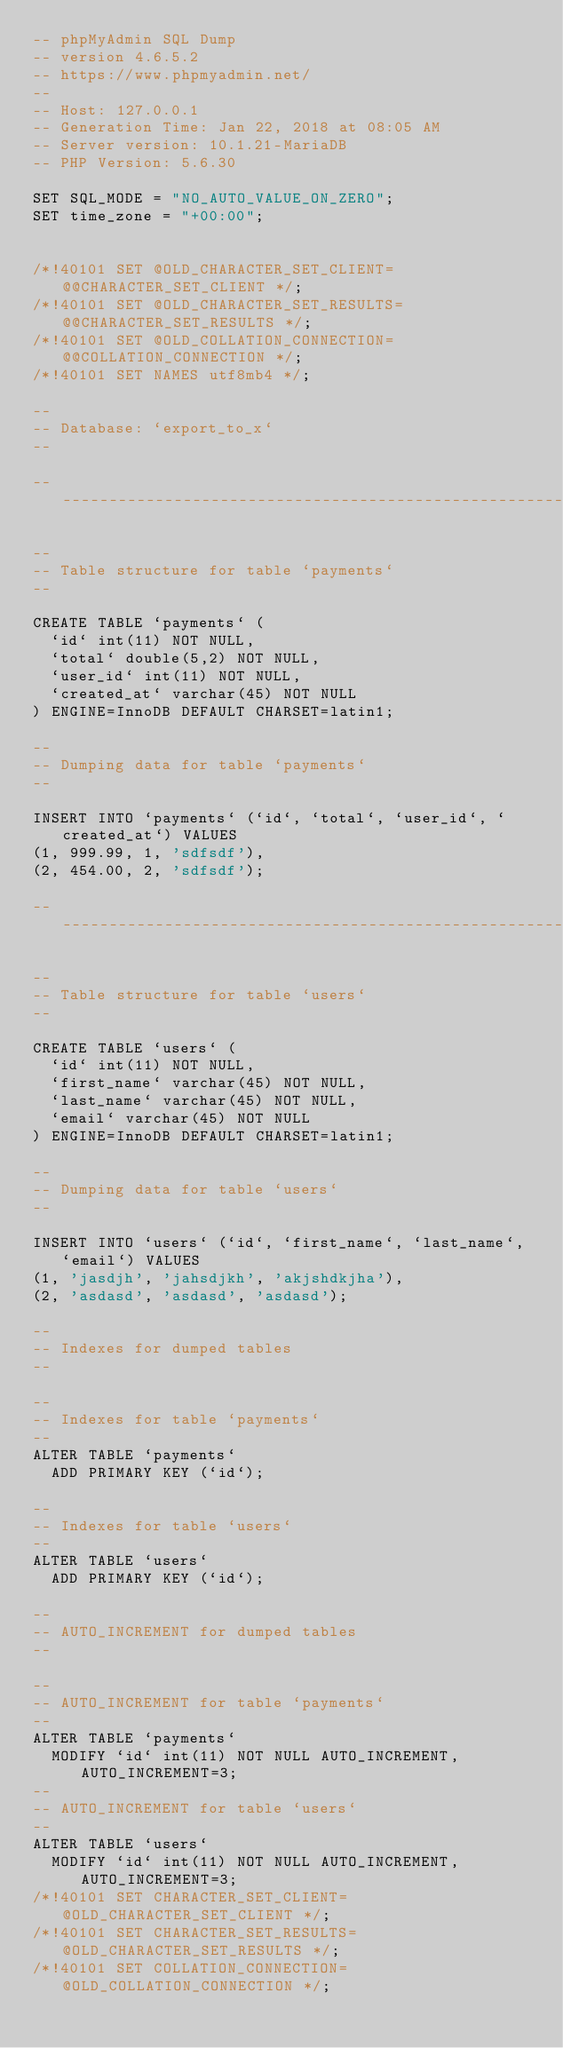<code> <loc_0><loc_0><loc_500><loc_500><_SQL_>-- phpMyAdmin SQL Dump
-- version 4.6.5.2
-- https://www.phpmyadmin.net/
--
-- Host: 127.0.0.1
-- Generation Time: Jan 22, 2018 at 08:05 AM
-- Server version: 10.1.21-MariaDB
-- PHP Version: 5.6.30

SET SQL_MODE = "NO_AUTO_VALUE_ON_ZERO";
SET time_zone = "+00:00";


/*!40101 SET @OLD_CHARACTER_SET_CLIENT=@@CHARACTER_SET_CLIENT */;
/*!40101 SET @OLD_CHARACTER_SET_RESULTS=@@CHARACTER_SET_RESULTS */;
/*!40101 SET @OLD_COLLATION_CONNECTION=@@COLLATION_CONNECTION */;
/*!40101 SET NAMES utf8mb4 */;

--
-- Database: `export_to_x`
--

-- --------------------------------------------------------

--
-- Table structure for table `payments`
--

CREATE TABLE `payments` (
  `id` int(11) NOT NULL,
  `total` double(5,2) NOT NULL,
  `user_id` int(11) NOT NULL,
  `created_at` varchar(45) NOT NULL
) ENGINE=InnoDB DEFAULT CHARSET=latin1;

--
-- Dumping data for table `payments`
--

INSERT INTO `payments` (`id`, `total`, `user_id`, `created_at`) VALUES
(1, 999.99, 1, 'sdfsdf'),
(2, 454.00, 2, 'sdfsdf');

-- --------------------------------------------------------

--
-- Table structure for table `users`
--

CREATE TABLE `users` (
  `id` int(11) NOT NULL,
  `first_name` varchar(45) NOT NULL,
  `last_name` varchar(45) NOT NULL,
  `email` varchar(45) NOT NULL
) ENGINE=InnoDB DEFAULT CHARSET=latin1;

--
-- Dumping data for table `users`
--

INSERT INTO `users` (`id`, `first_name`, `last_name`, `email`) VALUES
(1, 'jasdjh', 'jahsdjkh', 'akjshdkjha'),
(2, 'asdasd', 'asdasd', 'asdasd');

--
-- Indexes for dumped tables
--

--
-- Indexes for table `payments`
--
ALTER TABLE `payments`
  ADD PRIMARY KEY (`id`);

--
-- Indexes for table `users`
--
ALTER TABLE `users`
  ADD PRIMARY KEY (`id`);

--
-- AUTO_INCREMENT for dumped tables
--

--
-- AUTO_INCREMENT for table `payments`
--
ALTER TABLE `payments`
  MODIFY `id` int(11) NOT NULL AUTO_INCREMENT, AUTO_INCREMENT=3;
--
-- AUTO_INCREMENT for table `users`
--
ALTER TABLE `users`
  MODIFY `id` int(11) NOT NULL AUTO_INCREMENT, AUTO_INCREMENT=3;
/*!40101 SET CHARACTER_SET_CLIENT=@OLD_CHARACTER_SET_CLIENT */;
/*!40101 SET CHARACTER_SET_RESULTS=@OLD_CHARACTER_SET_RESULTS */;
/*!40101 SET COLLATION_CONNECTION=@OLD_COLLATION_CONNECTION */;
</code> 